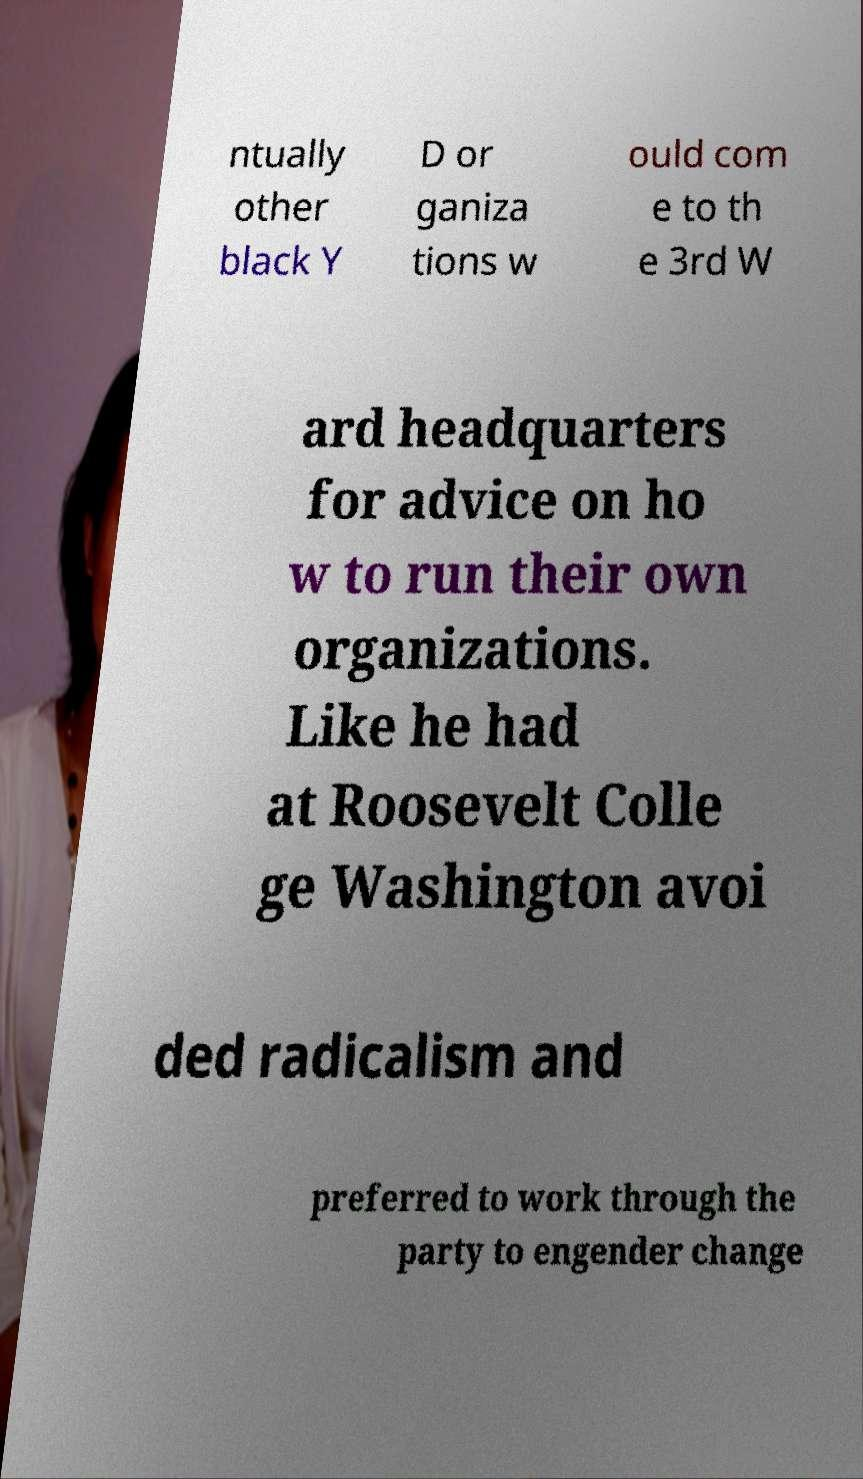What messages or text are displayed in this image? I need them in a readable, typed format. ntually other black Y D or ganiza tions w ould com e to th e 3rd W ard headquarters for advice on ho w to run their own organizations. Like he had at Roosevelt Colle ge Washington avoi ded radicalism and preferred to work through the party to engender change 